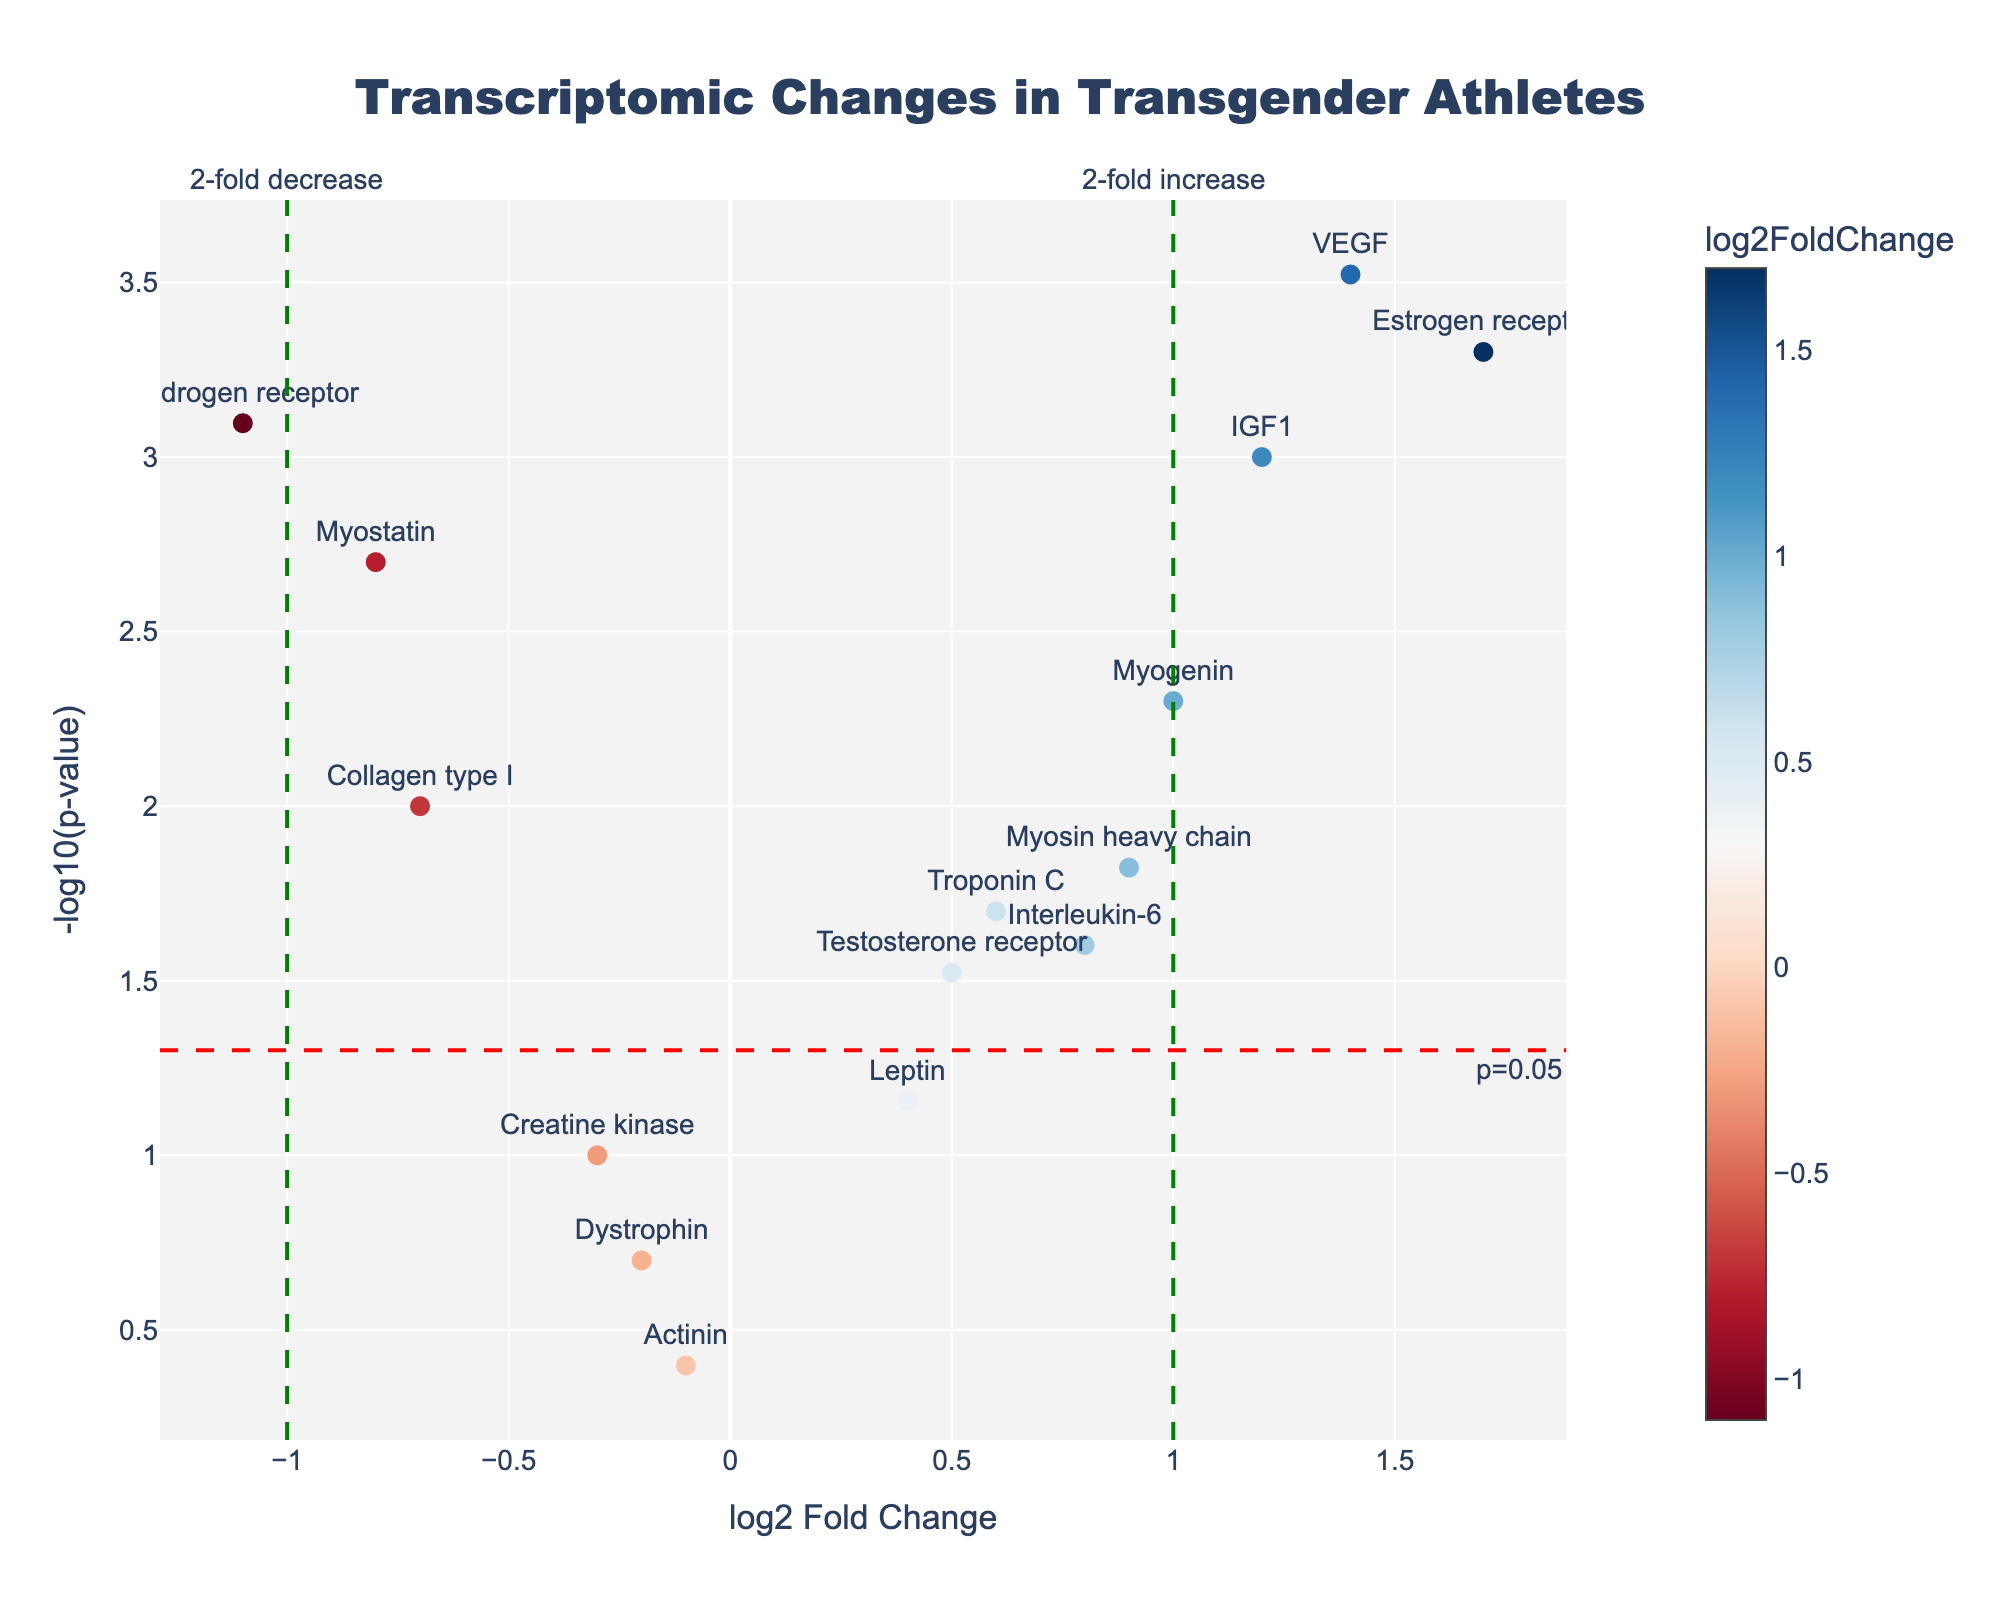How many data points are represented in the plot? Count the number of genes listed on the axis and the number of markers in the plot.
Answer: 15 What's the title of the plot? Read the text at the top of the plot.
Answer: Transcriptomic Changes in Transgender Athletes Which gene has the highest log2 fold change? Find the gene with the furthest marker to the right of the x-axis.
Answer: Estrogen receptor How many genes have a p-value below 0.05? Identify markers above the red horizontal line at y = -log10(0.05). There are markers for Myostatin, IGF1, Estrogen receptor, Myosin heavy chain, Troponin C, Androgen receptor, VEGF, Collagen type I, Interleukin-6, and Myogenin.
Answer: 10 Which gene shows the most significant up-regulation? Look for the gene with the highest positive log2 fold change and the highest y-value.
Answer: Estrogen receptor Which gene has the lowest log2 fold change? Find the gene with the furthest marker to the left of the x-axis.
Answer: Androgen receptor What is the log2 fold change for Myostatin? Locate Myostatin on the plot and read the x-axis value of its marker.
Answer: -0.8 Which gene has a p-value closest to 0.05 but still below it? Find the data point nearest but above the red threshold line for p-value = 0.05. Myosin heavy chain is closest to the threshold.
Answer: Myosin heavy chain How many genes have a log2 fold change greater than 1? Count markers to the right of the x=1 vertical line. Estrogen receptor, IGF1, VEGF, and Myogenin meet this criterion.
Answer: 4 Which genes are associated with muscle function and have significant changes (p < 0.05)? Identify muscle-related genes with markers above the p-value threshold line. IGF1, Troponin C, Myosin heavy chain, Collagen type I, and Myogenin are muscle-related and have significant changes.
Answer: IGF1, Troponin C, Myosin heavy chain, Collagen type I, Myogenin 